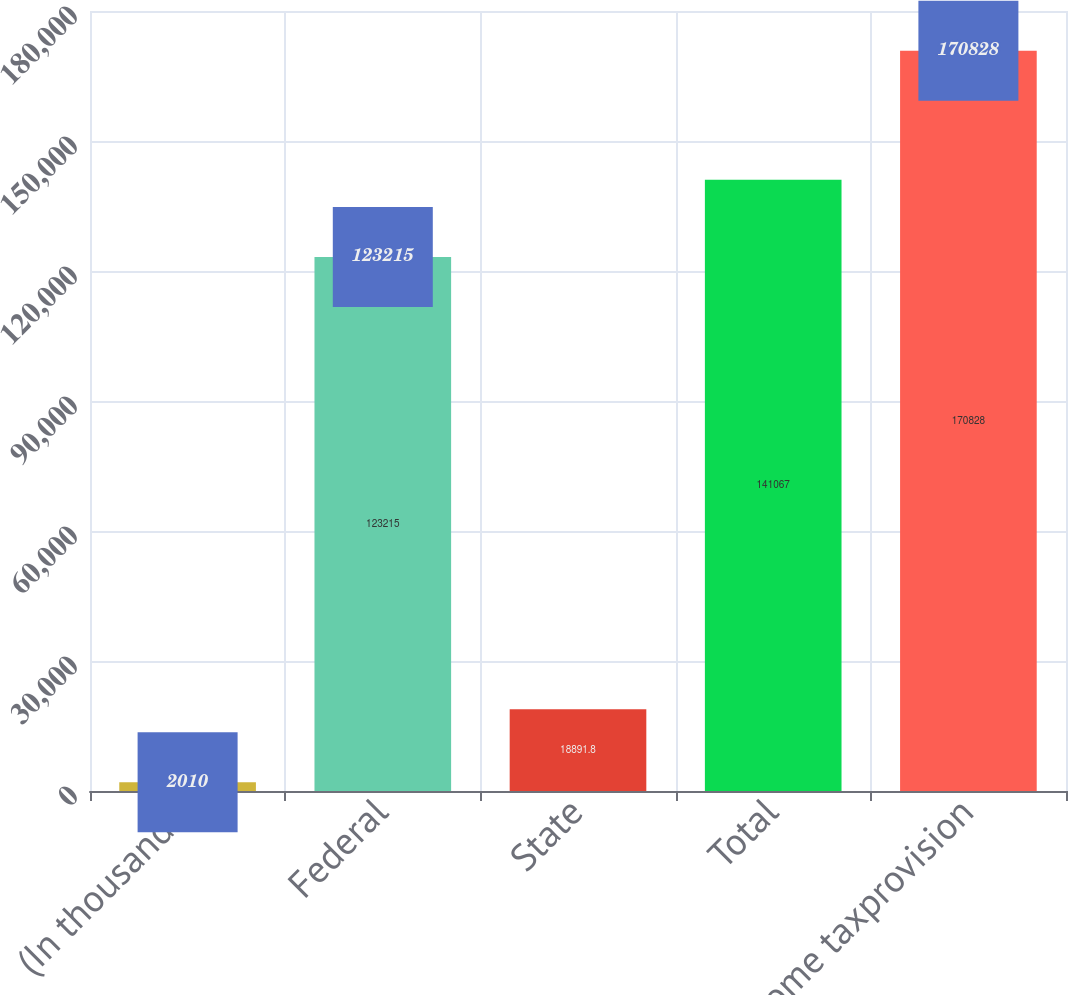Convert chart to OTSL. <chart><loc_0><loc_0><loc_500><loc_500><bar_chart><fcel>(In thousands)<fcel>Federal<fcel>State<fcel>Total<fcel>Income taxprovision<nl><fcel>2010<fcel>123215<fcel>18891.8<fcel>141067<fcel>170828<nl></chart> 